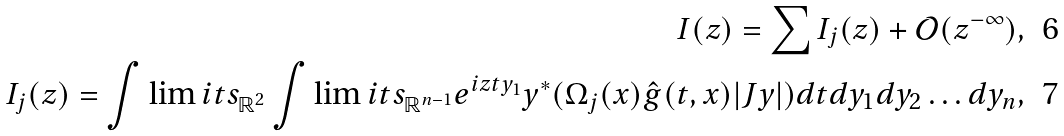<formula> <loc_0><loc_0><loc_500><loc_500>I ( z ) = \sum I _ { j } ( z ) + \mathcal { O } ( z ^ { - \infty } ) , \\ I _ { j } ( z ) = \int \lim i t s _ { \mathbb { R } ^ { 2 } } \int \lim i t s _ { \mathbb { R } ^ { n - 1 } } e ^ { i z t y _ { 1 } } y ^ { * } ( \Omega _ { j } ( x ) \hat { g } ( t , x ) | J y | ) d t d y _ { 1 } d y _ { 2 } \dots d y _ { n } ,</formula> 